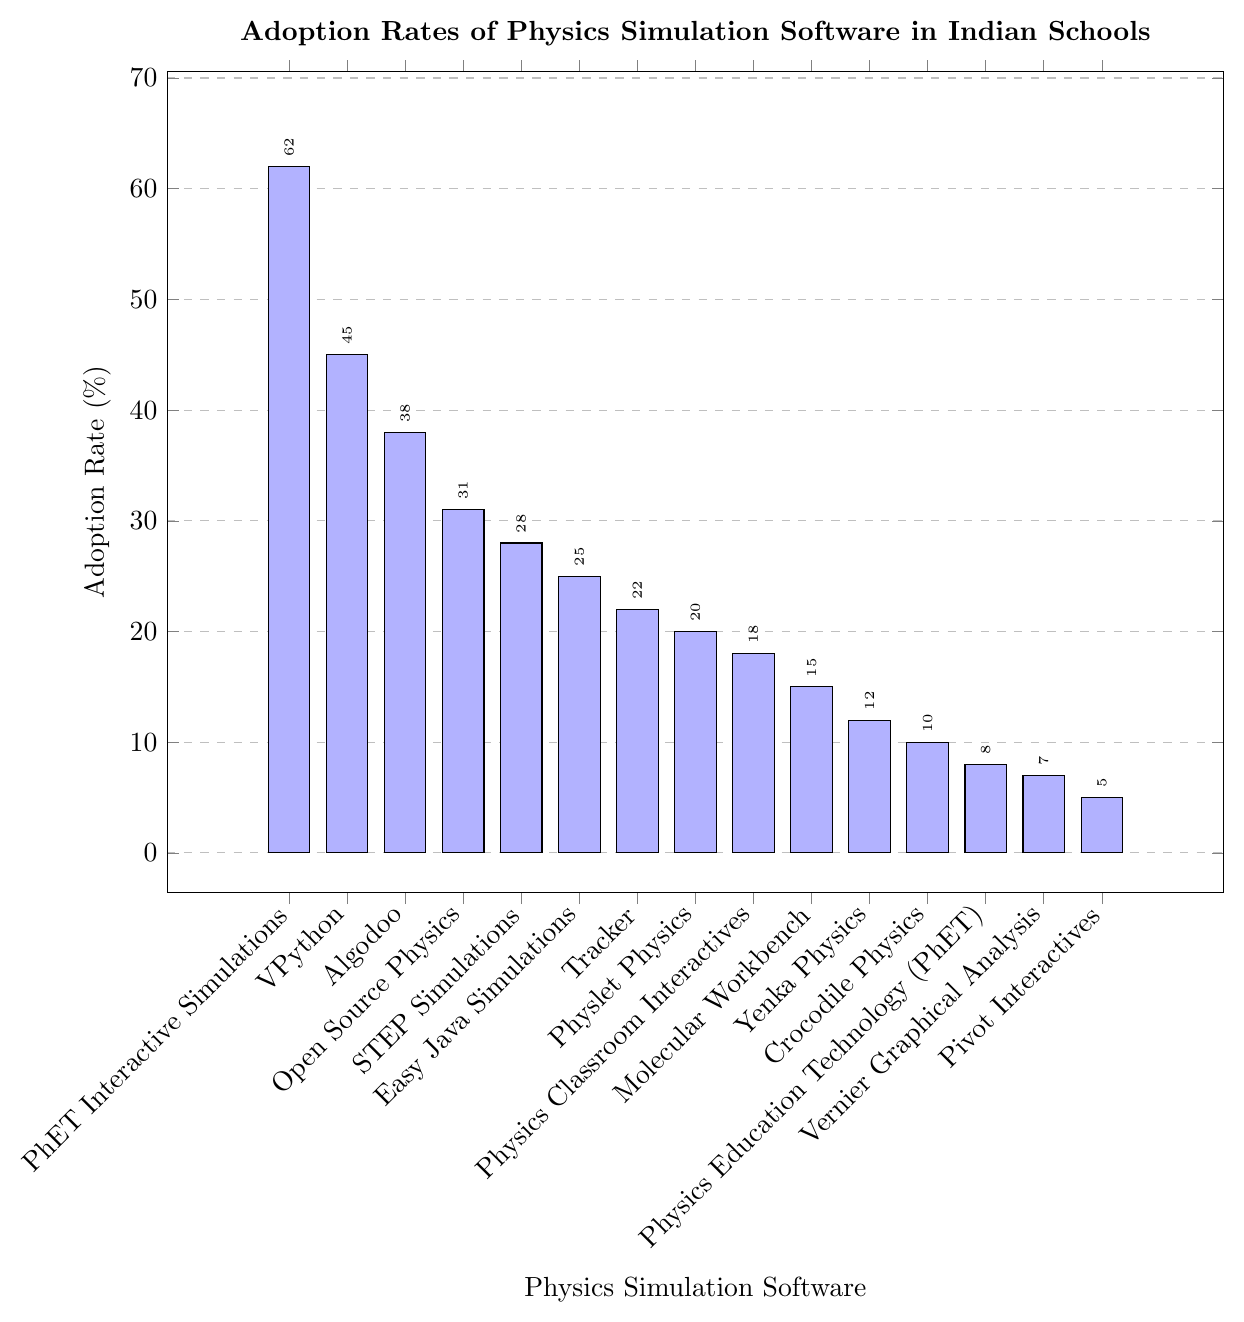Which software has the highest adoption rate? The bar chart shows the adoption rates for various physics simulation software. The software with the tallest bar corresponds to the highest adoption rate.
Answer: PhET Interactive Simulations What is the difference in adoption rate between PhET Interactive Simulations and VPython? The adoption rate for PhET Interactive Simulations is 62%, and for VPython, it is 45%. Subtract 45 from 62 to get the difference.
Answer: 17% Which software has the lowest adoption rate? The software with the shortest bar in the chart has the lowest adoption rate.
Answer: Pivot Interactives What is the average adoption rate of the top 3 software? The top 3 software by adoption rate are PhET Interactive Simulations (62%), VPython (45%), and Algodoo (38%). Add these rates and divide by 3: (62 + 45 + 38) / 3.
Answer: 48.33% How many software have adoption rates greater than 30%? Count the number of bars corresponding to adoption rates above 30%. This includes PhET Interactive Simulations (62%), VPython (45%), Algodoo (38%), and Open Source Physics (31%).
Answer: 4 Which software has adoption rates between 20% and 30% inclusive? Identify bars with heights corresponding to adoption rates between 20% and 30%. These are Easy Java Simulations (25%), Tracker (22%), and Physlet Physics (20%).
Answer: 3 What is the sum of adoption rates for Open Source Physics and Physics Classroom Interactives? Open Source Physics has an adoption rate of 31%, and Physics Classroom Interactives have 18%. Add these two rates together: 31 + 18.
Answer: 49% Describe the color gradient used in the bar chart. The bars transition from a blue hue for lower adoption rates to a red hue for higher adoption rates.
Answer: Blue to red What is the median adoption rate of all the listed software? To find the median, list all adoption rates in ascending order and find the middle value. The ordered list is: 5, 7, 8, 10, 12, 15, 18, 20, 22, 25, 28, 31, 38, 45, 62. The middle value (8th in a list of 15) is 20.
Answer: 20% By how much does the adoption rate of Crocodile Physics differ from Yenka Physics? Subtract the adoption rate of Crocodile Physics (10%) from Yenka Physics (12%).
Answer: 2% 